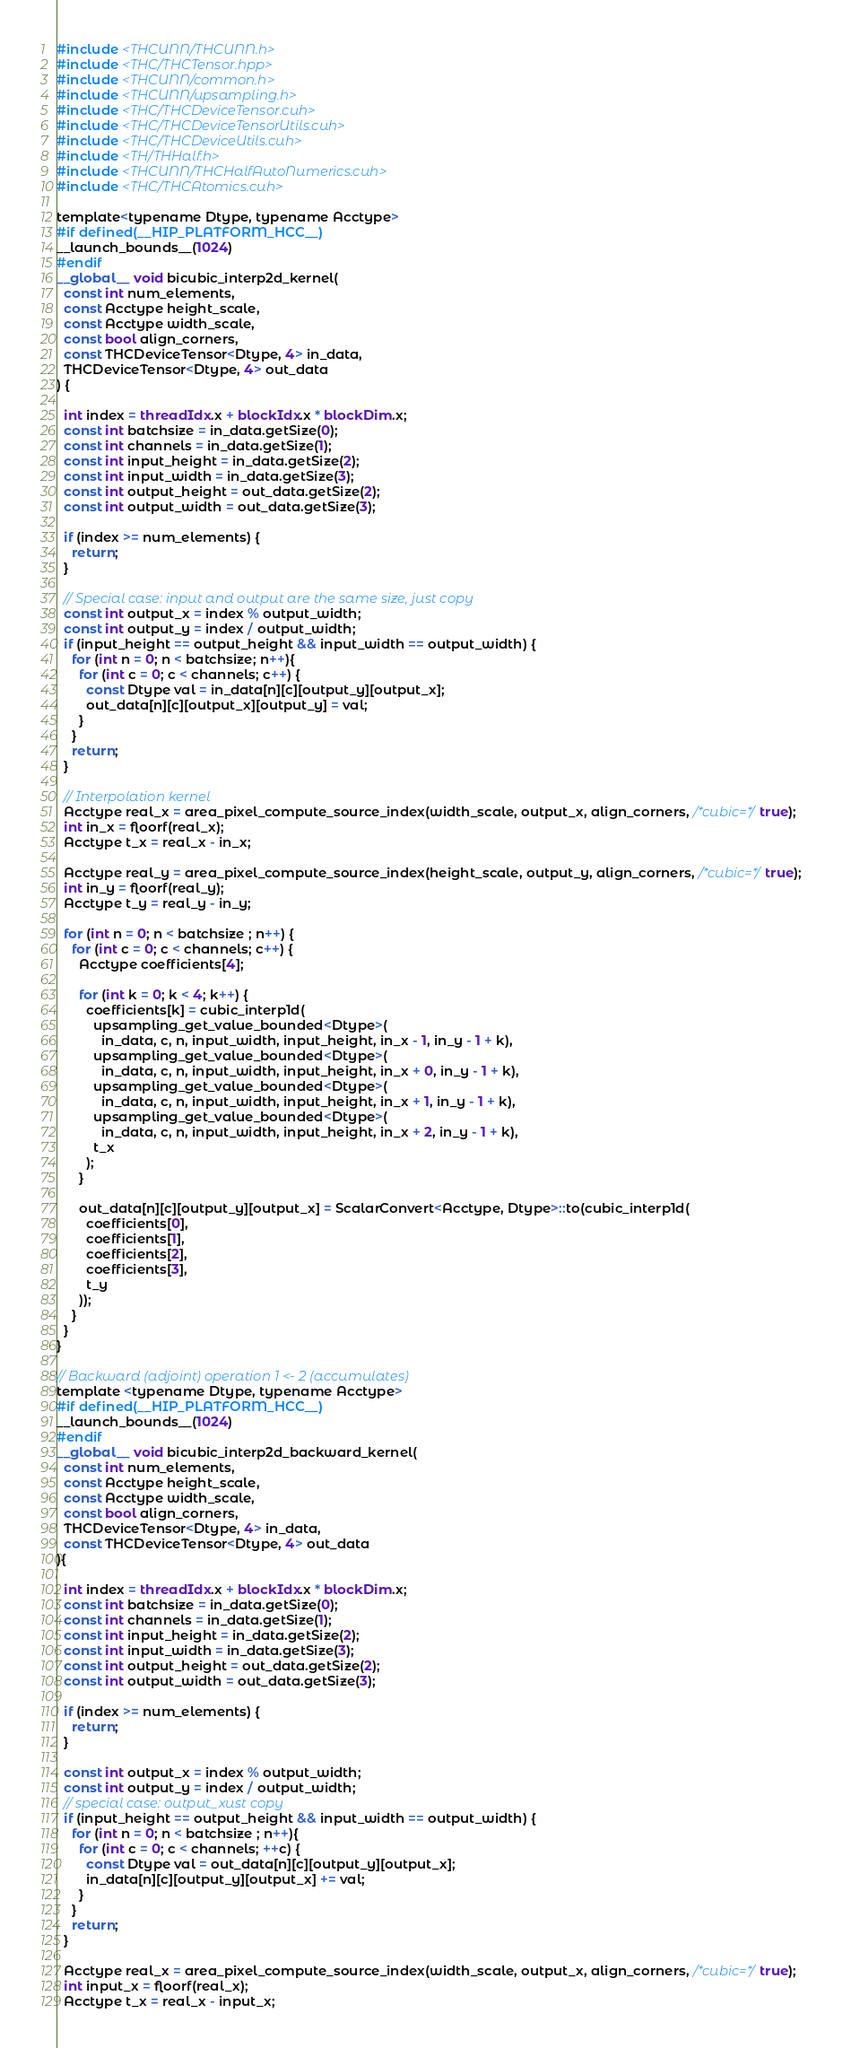<code> <loc_0><loc_0><loc_500><loc_500><_Cuda_>#include <THCUNN/THCUNN.h>
#include <THC/THCTensor.hpp>
#include <THCUNN/common.h>
#include <THCUNN/upsampling.h>
#include <THC/THCDeviceTensor.cuh>
#include <THC/THCDeviceTensorUtils.cuh>
#include <THC/THCDeviceUtils.cuh>
#include <TH/THHalf.h>
#include <THCUNN/THCHalfAutoNumerics.cuh>
#include <THC/THCAtomics.cuh>

template<typename Dtype, typename Acctype>
#if defined(__HIP_PLATFORM_HCC__)
__launch_bounds__(1024)
#endif
__global__ void bicubic_interp2d_kernel(
  const int num_elements,
  const Acctype height_scale,
  const Acctype width_scale,
  const bool align_corners,
  const THCDeviceTensor<Dtype, 4> in_data,
  THCDeviceTensor<Dtype, 4> out_data
) {

  int index = threadIdx.x + blockIdx.x * blockDim.x;
  const int batchsize = in_data.getSize(0);
  const int channels = in_data.getSize(1);
  const int input_height = in_data.getSize(2);
  const int input_width = in_data.getSize(3);
  const int output_height = out_data.getSize(2);
  const int output_width = out_data.getSize(3);

  if (index >= num_elements) {
    return;
  }

  // Special case: input and output are the same size, just copy
  const int output_x = index % output_width;
  const int output_y = index / output_width;
  if (input_height == output_height && input_width == output_width) {
    for (int n = 0; n < batchsize; n++){
      for (int c = 0; c < channels; c++) {
        const Dtype val = in_data[n][c][output_y][output_x];
        out_data[n][c][output_x][output_y] = val;
      }
    }
    return;
  }

  // Interpolation kernel
  Acctype real_x = area_pixel_compute_source_index(width_scale, output_x, align_corners, /*cubic=*/true);
  int in_x = floorf(real_x);
  Acctype t_x = real_x - in_x;

  Acctype real_y = area_pixel_compute_source_index(height_scale, output_y, align_corners, /*cubic=*/true);
  int in_y = floorf(real_y);
  Acctype t_y = real_y - in_y;

  for (int n = 0; n < batchsize ; n++) {
    for (int c = 0; c < channels; c++) {
      Acctype coefficients[4];

      for (int k = 0; k < 4; k++) {
        coefficients[k] = cubic_interp1d(
          upsampling_get_value_bounded<Dtype>(
            in_data, c, n, input_width, input_height, in_x - 1, in_y - 1 + k),
          upsampling_get_value_bounded<Dtype>(
            in_data, c, n, input_width, input_height, in_x + 0, in_y - 1 + k),
          upsampling_get_value_bounded<Dtype>(
            in_data, c, n, input_width, input_height, in_x + 1, in_y - 1 + k),
          upsampling_get_value_bounded<Dtype>(
            in_data, c, n, input_width, input_height, in_x + 2, in_y - 1 + k),
          t_x
        );
      }

      out_data[n][c][output_y][output_x] = ScalarConvert<Acctype, Dtype>::to(cubic_interp1d(
        coefficients[0],
        coefficients[1],
        coefficients[2],
        coefficients[3],
        t_y
      ));
    }
  }
}

// Backward (adjoint) operation 1 <- 2 (accumulates)
template <typename Dtype, typename Acctype>
#if defined(__HIP_PLATFORM_HCC__)
__launch_bounds__(1024)
#endif
__global__ void bicubic_interp2d_backward_kernel(
  const int num_elements,
  const Acctype height_scale,
  const Acctype width_scale,
  const bool align_corners,
  THCDeviceTensor<Dtype, 4> in_data,
  const THCDeviceTensor<Dtype, 4> out_data
){

  int index = threadIdx.x + blockIdx.x * blockDim.x;
  const int batchsize = in_data.getSize(0);
  const int channels = in_data.getSize(1);
  const int input_height = in_data.getSize(2);
  const int input_width = in_data.getSize(3);
  const int output_height = out_data.getSize(2);
  const int output_width = out_data.getSize(3);

  if (index >= num_elements) {
    return;
  }

  const int output_x = index % output_width;
  const int output_y = index / output_width;
  // special case: output_xust copy
  if (input_height == output_height && input_width == output_width) {
    for (int n = 0; n < batchsize ; n++){
      for (int c = 0; c < channels; ++c) {
        const Dtype val = out_data[n][c][output_y][output_x];
        in_data[n][c][output_y][output_x] += val;
      }
    }
    return;
  }

  Acctype real_x = area_pixel_compute_source_index(width_scale, output_x, align_corners, /*cubic=*/true);
  int input_x = floorf(real_x);
  Acctype t_x = real_x - input_x;
</code> 